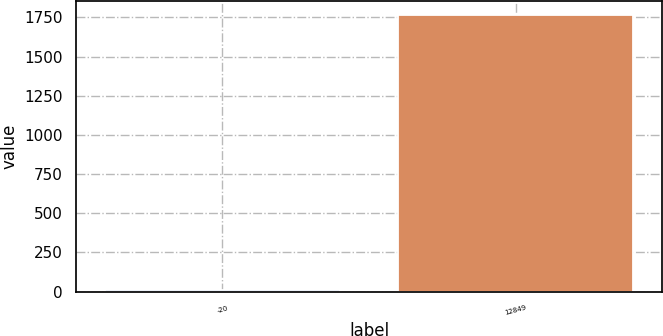Convert chart. <chart><loc_0><loc_0><loc_500><loc_500><bar_chart><fcel>-20<fcel>12849<nl><fcel>10<fcel>1766.8<nl></chart> 